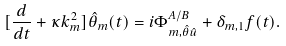Convert formula to latex. <formula><loc_0><loc_0><loc_500><loc_500>[ \frac { d } { d t } + \kappa k _ { m } ^ { 2 } ] { \hat { \theta } } _ { m } ( t ) = i \Phi ^ { A / B } _ { m , { \hat { \theta } } { \hat { u } } } + \delta _ { m , 1 } f ( t ) .</formula> 